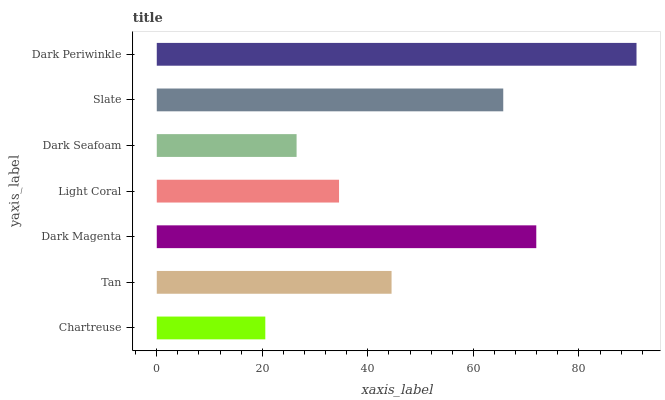Is Chartreuse the minimum?
Answer yes or no. Yes. Is Dark Periwinkle the maximum?
Answer yes or no. Yes. Is Tan the minimum?
Answer yes or no. No. Is Tan the maximum?
Answer yes or no. No. Is Tan greater than Chartreuse?
Answer yes or no. Yes. Is Chartreuse less than Tan?
Answer yes or no. Yes. Is Chartreuse greater than Tan?
Answer yes or no. No. Is Tan less than Chartreuse?
Answer yes or no. No. Is Tan the high median?
Answer yes or no. Yes. Is Tan the low median?
Answer yes or no. Yes. Is Light Coral the high median?
Answer yes or no. No. Is Dark Magenta the low median?
Answer yes or no. No. 